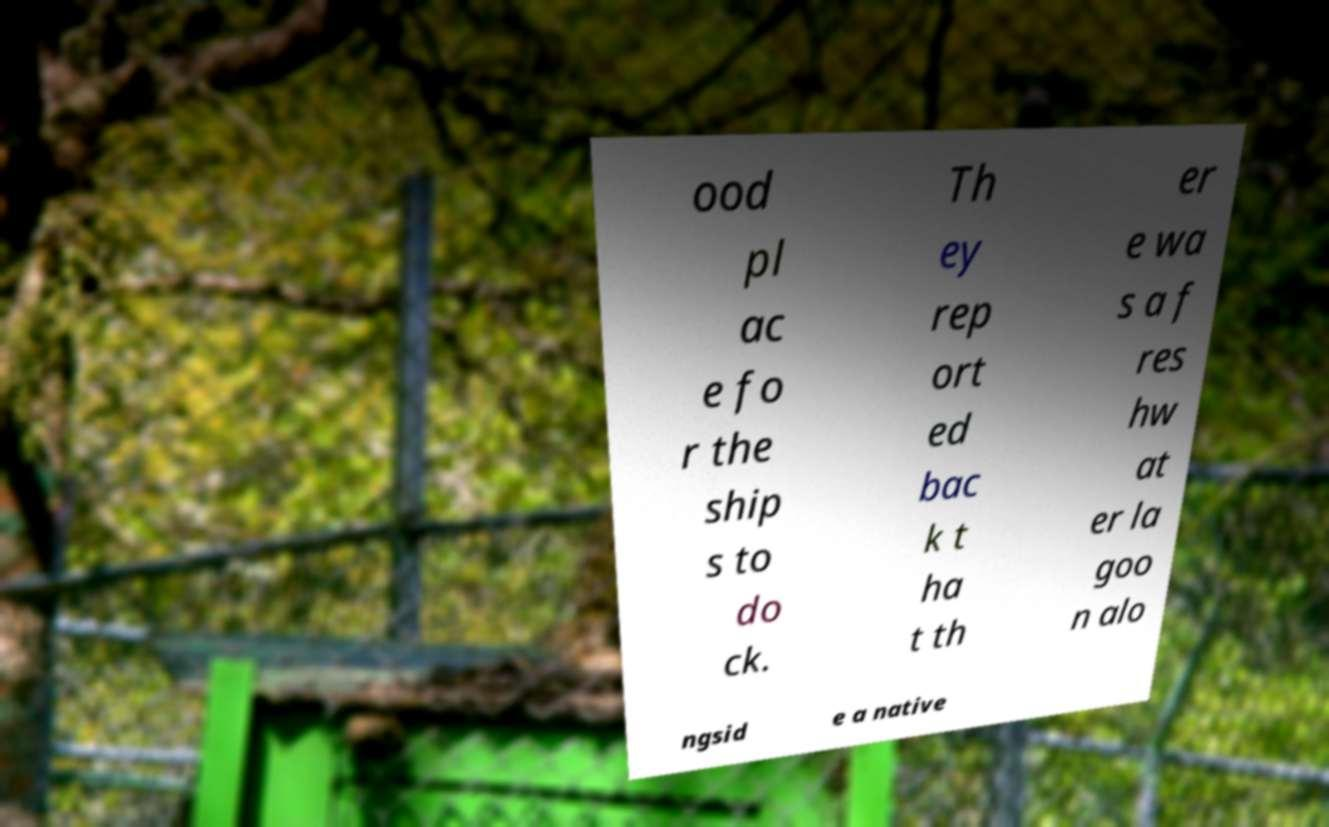Can you accurately transcribe the text from the provided image for me? ood pl ac e fo r the ship s to do ck. Th ey rep ort ed bac k t ha t th er e wa s a f res hw at er la goo n alo ngsid e a native 